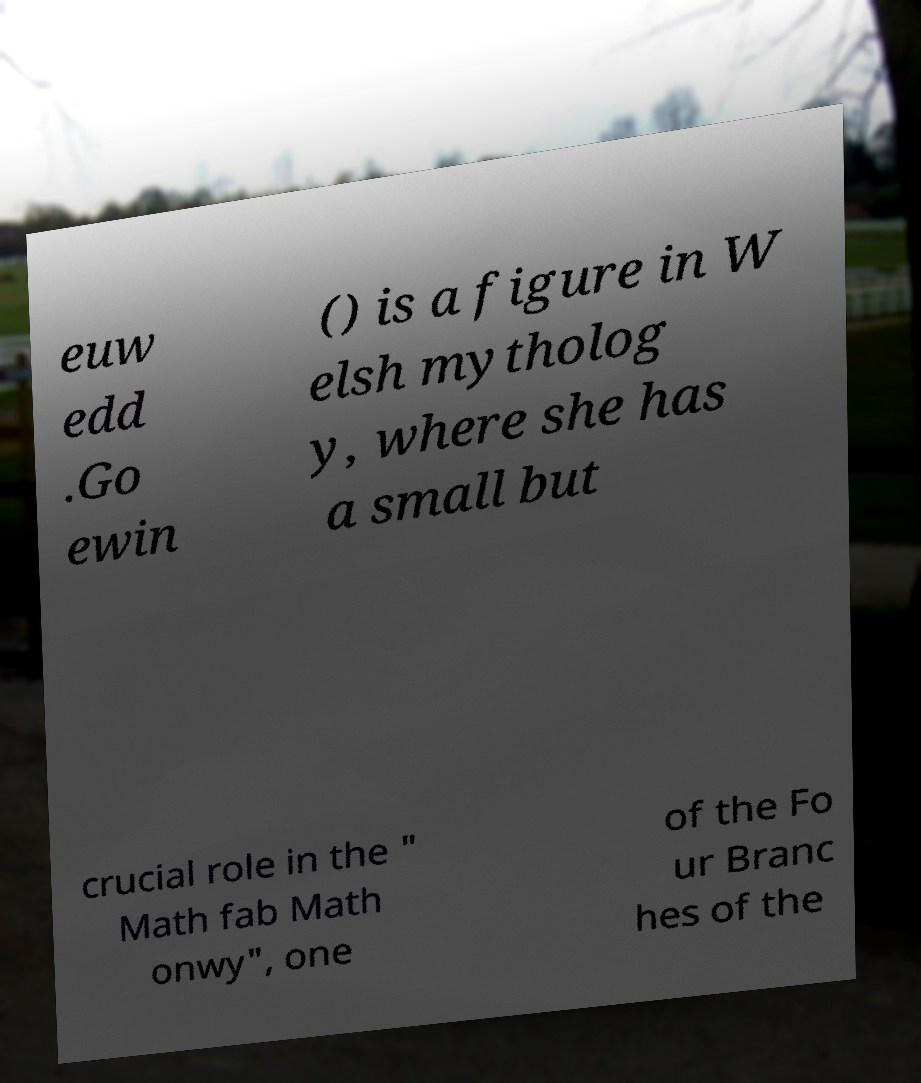Could you assist in decoding the text presented in this image and type it out clearly? euw edd .Go ewin () is a figure in W elsh mytholog y, where she has a small but crucial role in the " Math fab Math onwy", one of the Fo ur Branc hes of the 